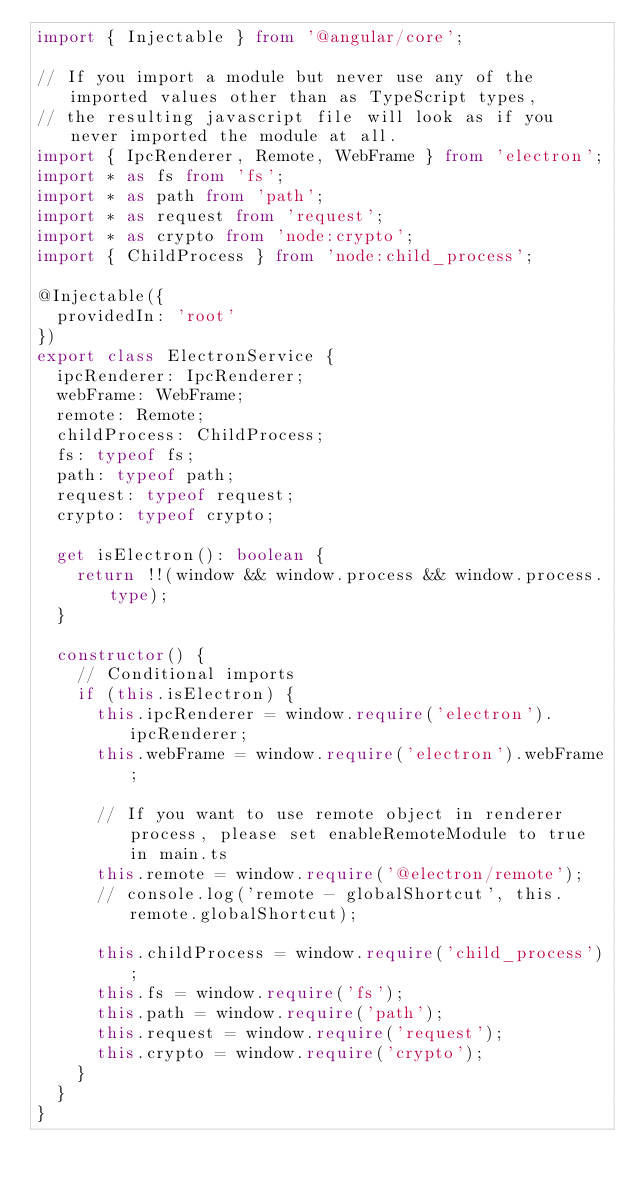Convert code to text. <code><loc_0><loc_0><loc_500><loc_500><_TypeScript_>import { Injectable } from '@angular/core';

// If you import a module but never use any of the imported values other than as TypeScript types,
// the resulting javascript file will look as if you never imported the module at all.
import { IpcRenderer, Remote, WebFrame } from 'electron';
import * as fs from 'fs';
import * as path from 'path';
import * as request from 'request';
import * as crypto from 'node:crypto';
import { ChildProcess } from 'node:child_process';

@Injectable({
  providedIn: 'root'
})
export class ElectronService {
  ipcRenderer: IpcRenderer;
  webFrame: WebFrame;
  remote: Remote;
  childProcess: ChildProcess;
  fs: typeof fs;
  path: typeof path;
  request: typeof request;
  crypto: typeof crypto;

  get isElectron(): boolean {
    return !!(window && window.process && window.process.type);
  }

  constructor() {
    // Conditional imports
    if (this.isElectron) {
      this.ipcRenderer = window.require('electron').ipcRenderer;
      this.webFrame = window.require('electron').webFrame;

      // If you want to use remote object in renderer process, please set enableRemoteModule to true in main.ts
      this.remote = window.require('@electron/remote');
      // console.log('remote - globalShortcut', this.remote.globalShortcut);

      this.childProcess = window.require('child_process');
      this.fs = window.require('fs');
      this.path = window.require('path');
      this.request = window.require('request');
      this.crypto = window.require('crypto');
    }
  }
}
</code> 